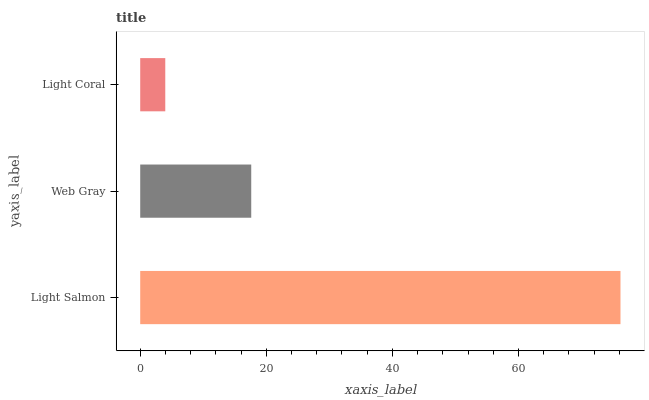Is Light Coral the minimum?
Answer yes or no. Yes. Is Light Salmon the maximum?
Answer yes or no. Yes. Is Web Gray the minimum?
Answer yes or no. No. Is Web Gray the maximum?
Answer yes or no. No. Is Light Salmon greater than Web Gray?
Answer yes or no. Yes. Is Web Gray less than Light Salmon?
Answer yes or no. Yes. Is Web Gray greater than Light Salmon?
Answer yes or no. No. Is Light Salmon less than Web Gray?
Answer yes or no. No. Is Web Gray the high median?
Answer yes or no. Yes. Is Web Gray the low median?
Answer yes or no. Yes. Is Light Coral the high median?
Answer yes or no. No. Is Light Salmon the low median?
Answer yes or no. No. 